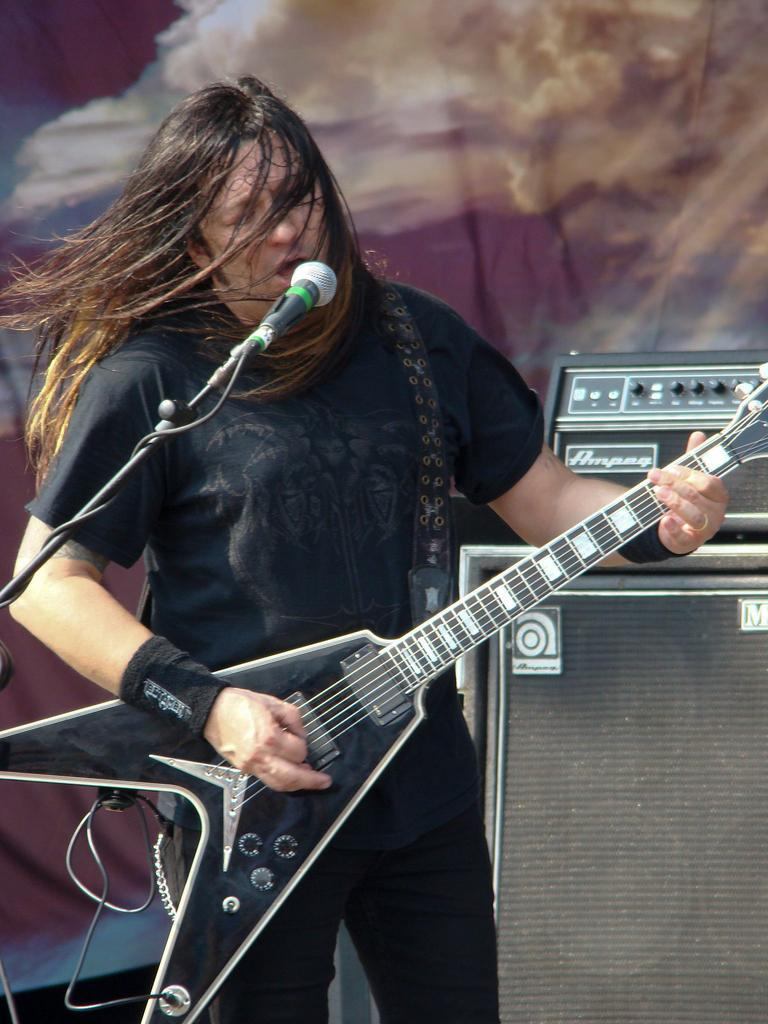What is the main subject of the image? There is a person in the image. What is the person doing in the image? The person is standing and playing a guitar. What is in front of the person? There is a microphone in front of the person. What else can be seen in the image? There are objects in the image that look like speakers. What type of office equipment can be seen in the image? There is no office equipment present in the image. What arithmetic problem is the person solving in the image? There is no arithmetic problem being solved in the image; the person is playing a guitar. 